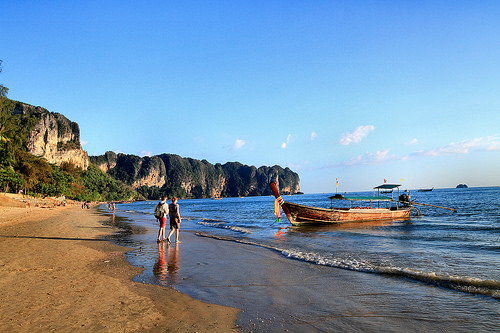<image>
Can you confirm if the person is behind the boat? No. The person is not behind the boat. From this viewpoint, the person appears to be positioned elsewhere in the scene. 